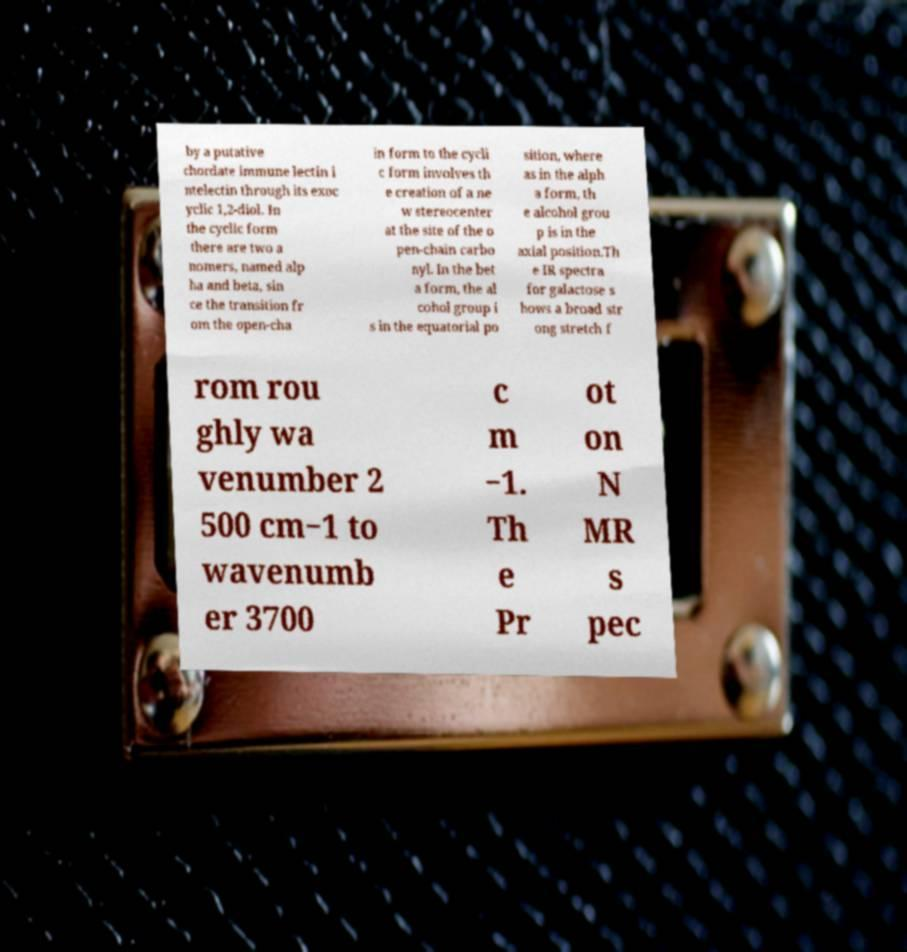I need the written content from this picture converted into text. Can you do that? by a putative chordate immune lectin i ntelectin through its exoc yclic 1,2-diol. In the cyclic form there are two a nomers, named alp ha and beta, sin ce the transition fr om the open-cha in form to the cycli c form involves th e creation of a ne w stereocenter at the site of the o pen-chain carbo nyl. In the bet a form, the al cohol group i s in the equatorial po sition, where as in the alph a form, th e alcohol grou p is in the axial position.Th e IR spectra for galactose s hows a broad str ong stretch f rom rou ghly wa venumber 2 500 cm−1 to wavenumb er 3700 c m −1. Th e Pr ot on N MR s pec 